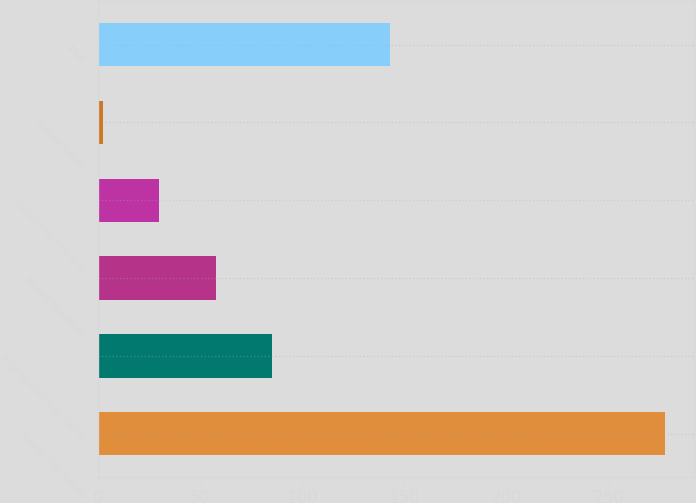<chart> <loc_0><loc_0><loc_500><loc_500><bar_chart><fcel>Mileage Plan current<fcel>Property and transportation<fcel>Interest rate swaps<fcel>Postretirement medical<fcel>Pension liability<fcel>Other<nl><fcel>278<fcel>85.01<fcel>57.44<fcel>29.87<fcel>2.3<fcel>143<nl></chart> 